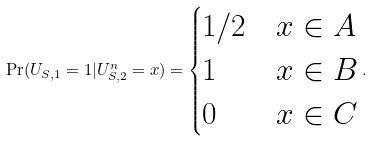<formula> <loc_0><loc_0><loc_500><loc_500>\Pr ( U _ { S , 1 } = 1 | U _ { S , 2 } ^ { n } = x ) = \begin{cases} 1 / 2 & x \in A \\ 1 & x \in B \\ 0 & x \in C \end{cases} .</formula> 